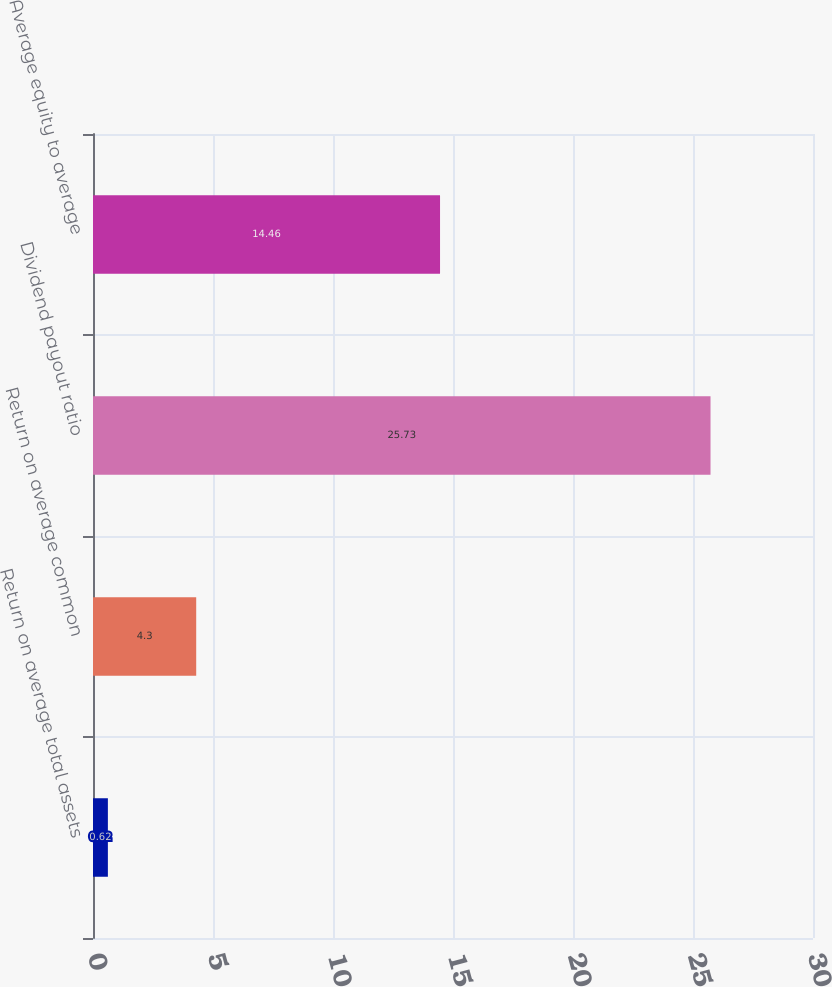Convert chart. <chart><loc_0><loc_0><loc_500><loc_500><bar_chart><fcel>Return on average total assets<fcel>Return on average common<fcel>Dividend payout ratio<fcel>Average equity to average<nl><fcel>0.62<fcel>4.3<fcel>25.73<fcel>14.46<nl></chart> 